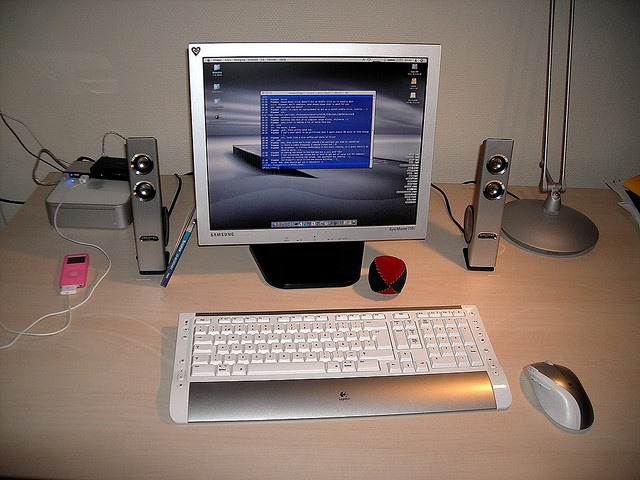Describe the objects in this image and their specific colors. I can see tv in black, gray, darkgray, and navy tones, keyboard in black, lightgray, darkgray, and gray tones, and mouse in black, darkgray, and gray tones in this image. 